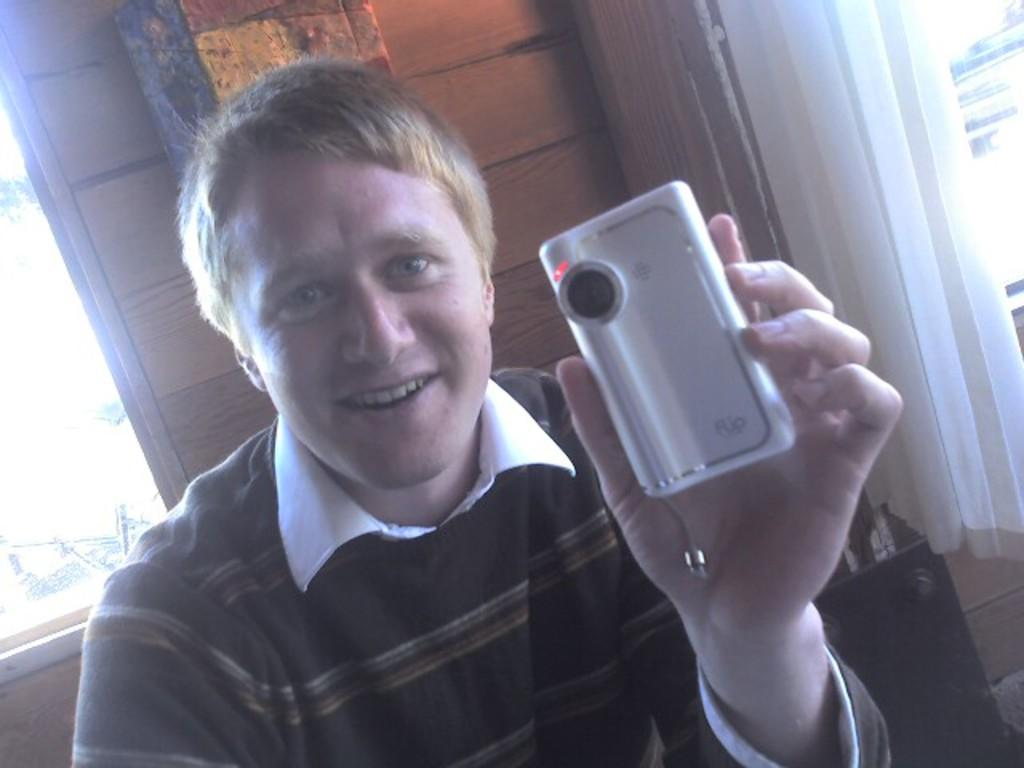What is the man in the image holding? The man is holding a device in the image. What type of structure can be seen in the background of the image? There is a wooden wall visible in the image. What feature of the wooden wall is mentioned in the facts? The wooden wall has windows, and there is a curtain associated with the windows. What type of soap is the man using to clean the plough in the image? There is no plough or soap present in the image. What point is the man trying to make with the device in the image? The facts do not mention any specific point the man is trying to make with the device. 